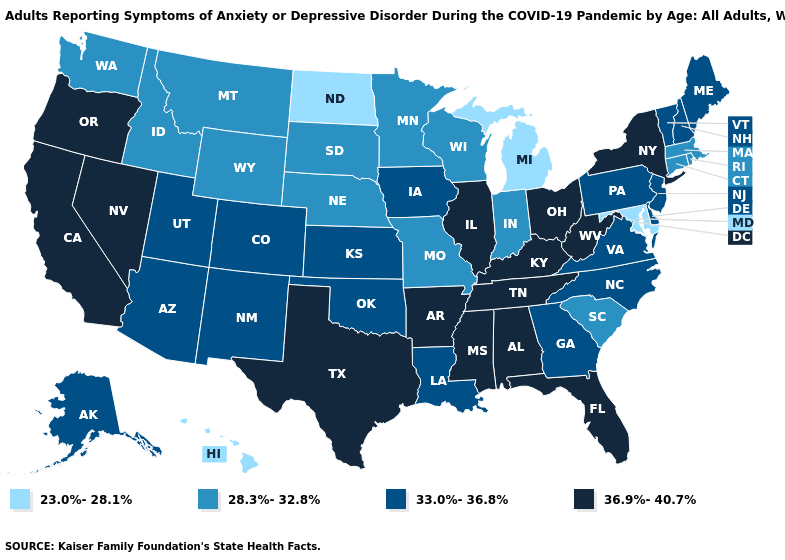Among the states that border Michigan , which have the lowest value?
Concise answer only. Indiana, Wisconsin. What is the value of New Hampshire?
Be succinct. 33.0%-36.8%. What is the value of New Hampshire?
Answer briefly. 33.0%-36.8%. Among the states that border Delaware , does Pennsylvania have the lowest value?
Write a very short answer. No. Which states have the highest value in the USA?
Answer briefly. Alabama, Arkansas, California, Florida, Illinois, Kentucky, Mississippi, Nevada, New York, Ohio, Oregon, Tennessee, Texas, West Virginia. Does Nevada have the same value as Massachusetts?
Short answer required. No. Name the states that have a value in the range 23.0%-28.1%?
Concise answer only. Hawaii, Maryland, Michigan, North Dakota. What is the value of North Dakota?
Answer briefly. 23.0%-28.1%. Name the states that have a value in the range 23.0%-28.1%?
Be succinct. Hawaii, Maryland, Michigan, North Dakota. Does the map have missing data?
Write a very short answer. No. Does North Dakota have the lowest value in the MidWest?
Concise answer only. Yes. What is the value of Indiana?
Keep it brief. 28.3%-32.8%. How many symbols are there in the legend?
Be succinct. 4. Does Georgia have the highest value in the South?
Short answer required. No. Does Hawaii have the lowest value in the USA?
Be succinct. Yes. 